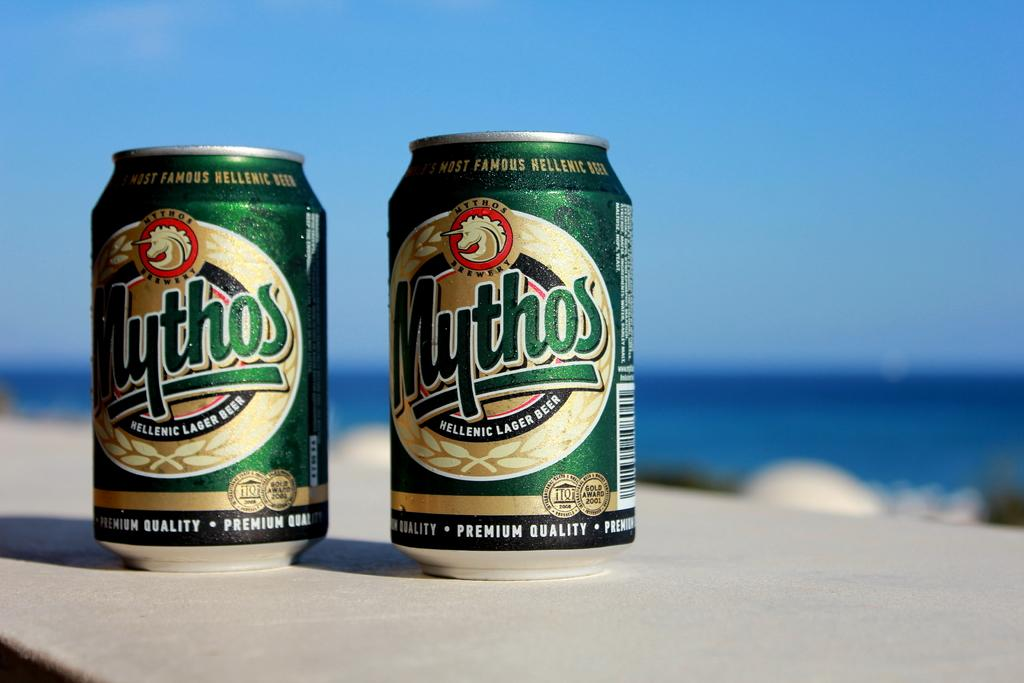<image>
Render a clear and concise summary of the photo. 2 can of Mythos lager beer sitting outside with a blue sky in the background. 